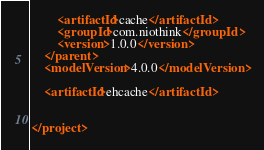Convert code to text. <code><loc_0><loc_0><loc_500><loc_500><_XML_>        <artifactId>cache</artifactId>
        <groupId>com.niothink</groupId>
        <version>1.0.0</version>
    </parent>
    <modelVersion>4.0.0</modelVersion>

    <artifactId>ehcache</artifactId>


</project></code> 